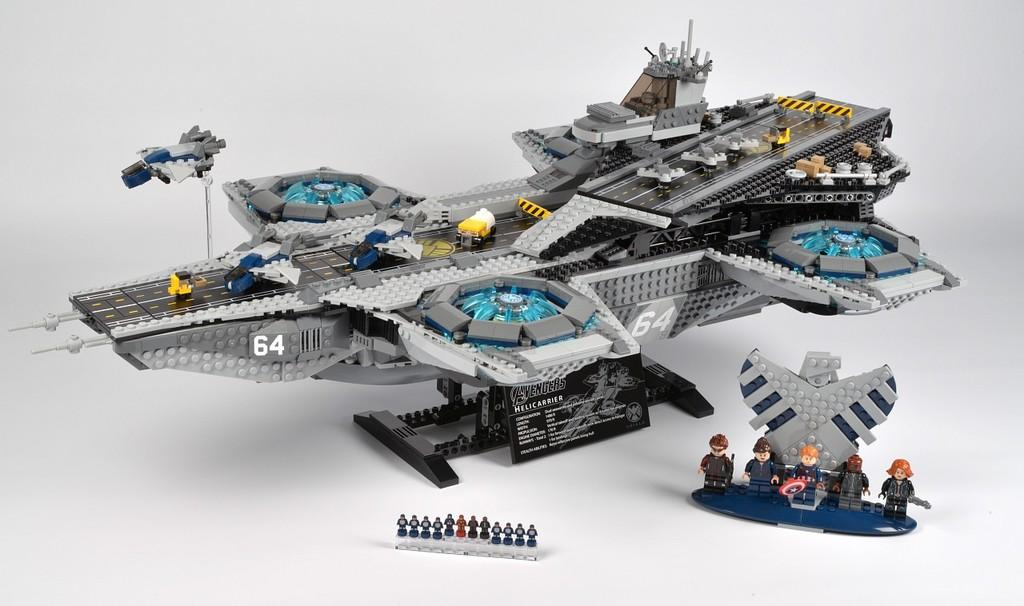What type of gadget is visible in the image? There is a remote control gadget in the image. Can you describe the different parts of the remote control gadget? The remote control gadget has various different parts. What type of farm animals can be seen in the image? There are no farm animals present in the image; it features a remote control gadget. What is the cause of the thunder in the image? There is no thunder present in the image; it features a remote control gadget. 